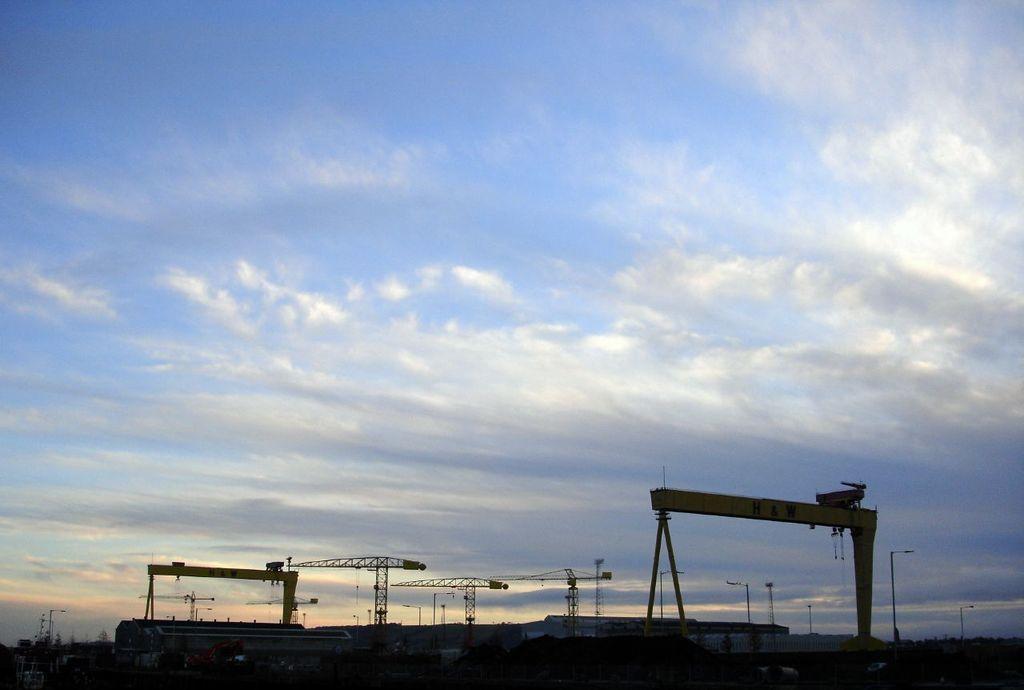How would you summarize this image in a sentence or two? Here in this picture we can see crane lifts present on the ground and we can also see other machinery also present on the ground and in the far we can see plants and trees present and we can see light posts present and we can see sky is covered with clouds. 